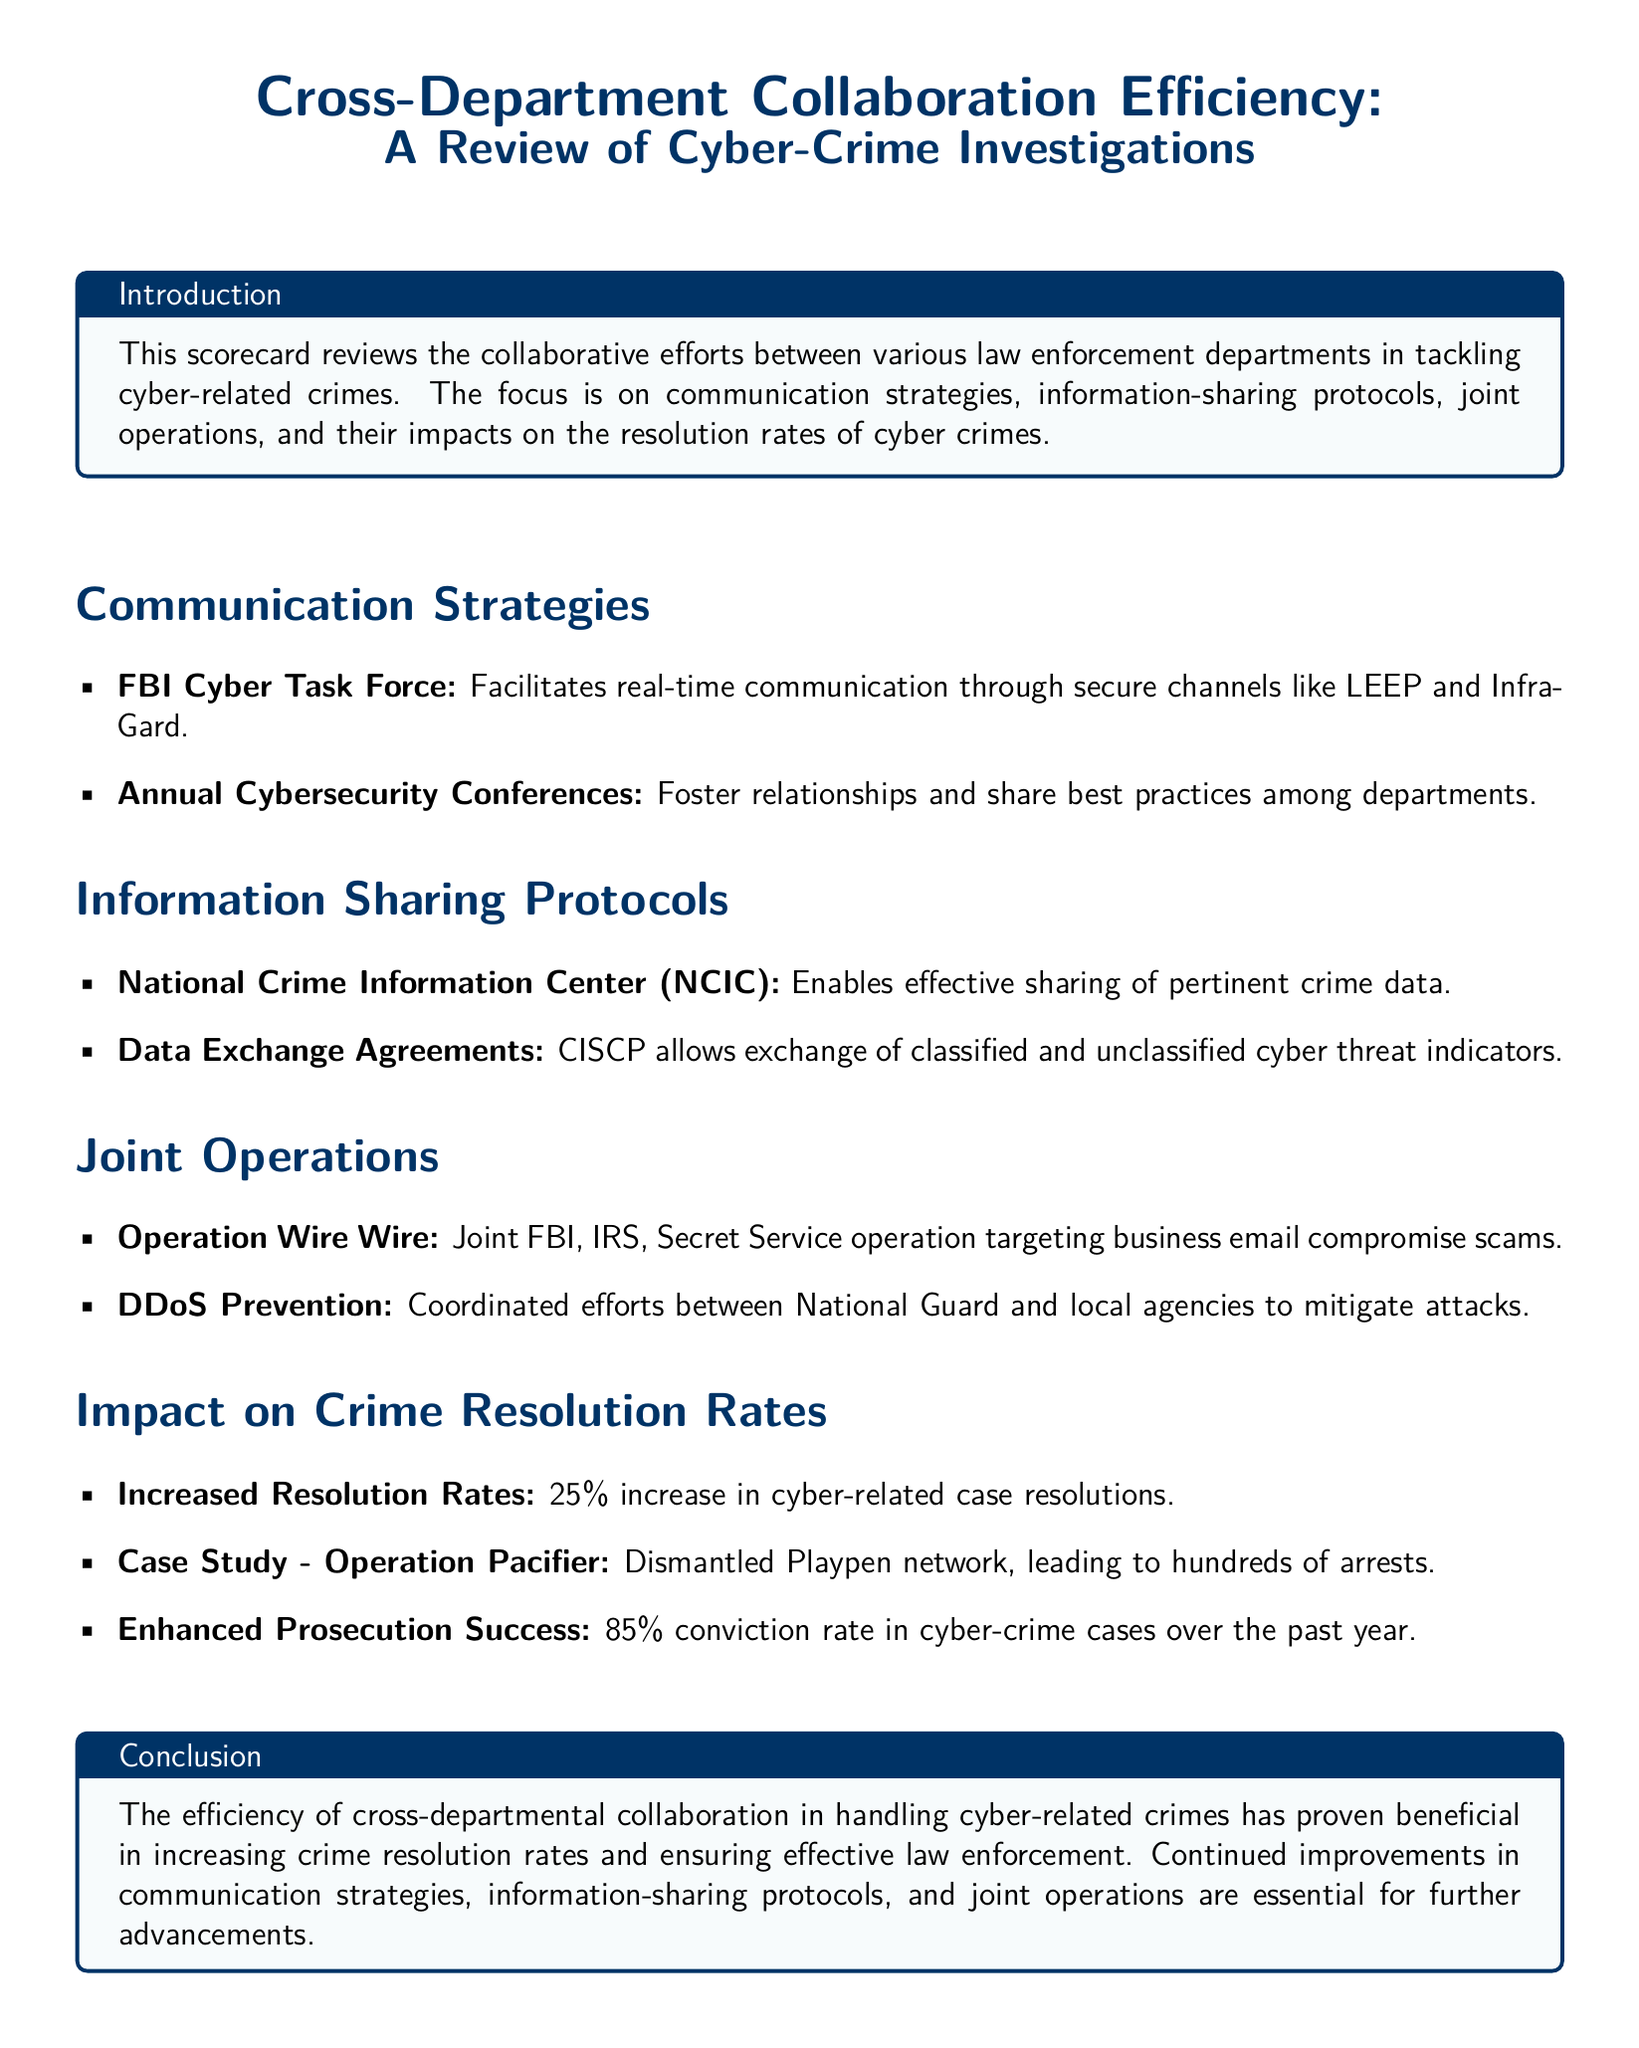What is the name of the FBI cybersecurity initiative mentioned? The document lists the FBI Cyber Task Force as a key initiative for communication in cyber-related crime investigations.
Answer: FBI Cyber Task Force What percentage increase in cyber-related case resolutions is noted? The document states there is a 25% increase in the resolution rates of cyber-related cases.
Answer: 25% Which operation targeted business email compromise scams? The document mentions Operation Wire Wire as the joint operation targeting business email compromise scams.
Answer: Operation Wire Wire What is the conviction rate in cyber-crime cases over the past year? The document indicates an 85% conviction rate in cyber-crime cases for the previous year.
Answer: 85% What data-sharing platform allows exchange of cyber threat indicators? The document refers to CISCP as the platform that enables the exchange of classified and unclassified cyber threat indicators.
Answer: CISCP What is the overall impact of cross-department collaboration on crime resolution rates? The document highlights the overall effect of collaboration as beneficial, with a specific mention of increased crime resolution rates.
Answer: Increased resolution rates Which operation led to the dismantling of the Playpen network? The document cites Operation Pacifier as the operation that dismantled the Playpen network.
Answer: Operation Pacifier What event fosters relationships and shares best practices among law enforcement departments? The document mentions Annual Cybersecurity Conferences as an event that fosters relationships and sharing best practices.
Answer: Annual Cybersecurity Conferences What agency coordinated efforts to mitigate DDoS attacks? The document states that the National Guard coordinated efforts with local agencies to mitigate DDoS attacks.
Answer: National Guard 